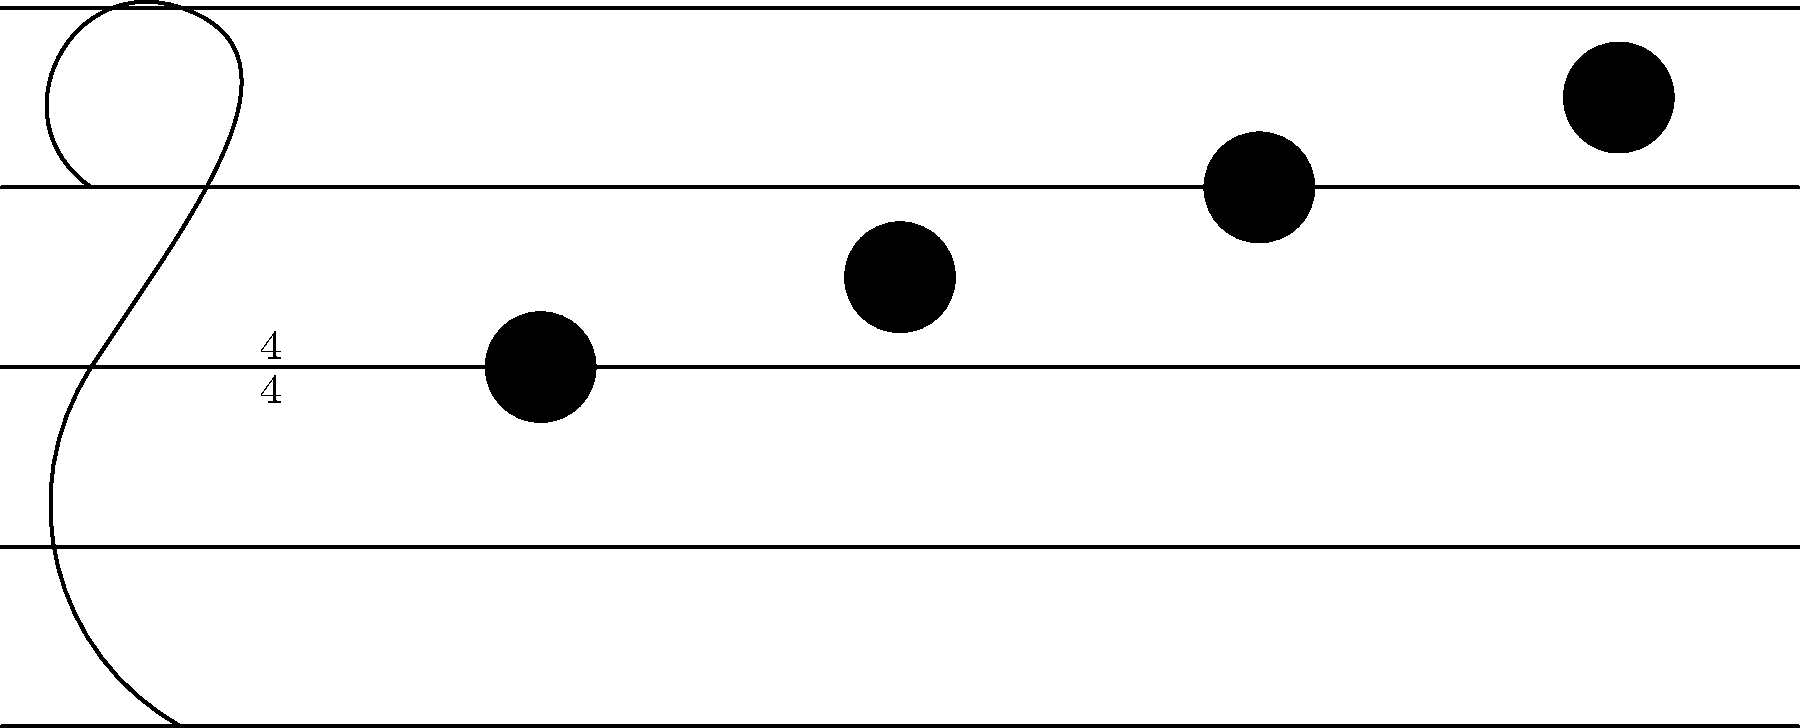As a music app developer, you're implementing a feature to automatically detect chord progressions. Given the simplified musical staff notation above, what is the most likely chord progression represented by these notes? To determine the chord progression, we need to analyze the notes on the staff:

1. Identify the notes:
   - First note: On the 2nd line from bottom = G
   - Second note: In the 2nd space from bottom = A
   - Third note: On the 3rd line from bottom = B
   - Fourth note: In the 3rd space from bottom = C

2. Analyze the chord structure:
   - The notes ascend stepwise from G to C
   - This suggests a progression based on the G major scale

3. Determine likely chords:
   - G (I chord): G-B-D (G and B are present)
   - Am (ii chord): A-C-E (A and C are present)
   - C (IV chord): C-E-G (C and G are present)

4. Consider common progressions:
   - A very common progression in popular music is I-V-vi-IV
   - In the key of G, this would be G-D-Em-C

5. Match the notes to the progression:
   - G fits with the I chord (G)
   - A could be part of the vi chord (Em)
   - B fits back with the I chord (G)
   - C matches the IV chord (C)

Therefore, the most likely chord progression represented by these notes, considering common patterns and the notes present, is G-Em-G-C or I-vi-I-IV in Roman numeral notation.
Answer: I-vi-I-IV 